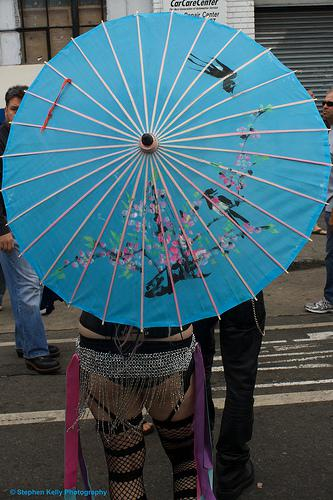Question: where is the picture taken?
Choices:
A. Near the beach.
B. At the carnival.
C. On the street.
D. In my bathroom.
Answer with the letter. Answer: C Question: what is the lady wearing?
Choices:
A. A pink purse.
B. A studded belt.
C. A blonde wig.
D. A nice shade of red lipstick.
Answer with the letter. Answer: B Question: what kind of shoes is the man on the right wearing?
Choices:
A. Cowboy boots.
B. Steel toe boots.
C. Flip flops.
D. Sneakers.
Answer with the letter. Answer: D 